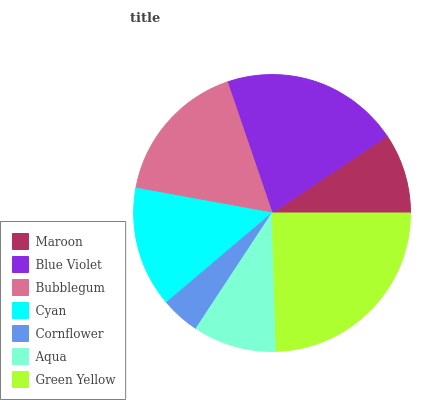Is Cornflower the minimum?
Answer yes or no. Yes. Is Green Yellow the maximum?
Answer yes or no. Yes. Is Blue Violet the minimum?
Answer yes or no. No. Is Blue Violet the maximum?
Answer yes or no. No. Is Blue Violet greater than Maroon?
Answer yes or no. Yes. Is Maroon less than Blue Violet?
Answer yes or no. Yes. Is Maroon greater than Blue Violet?
Answer yes or no. No. Is Blue Violet less than Maroon?
Answer yes or no. No. Is Cyan the high median?
Answer yes or no. Yes. Is Cyan the low median?
Answer yes or no. Yes. Is Cornflower the high median?
Answer yes or no. No. Is Aqua the low median?
Answer yes or no. No. 